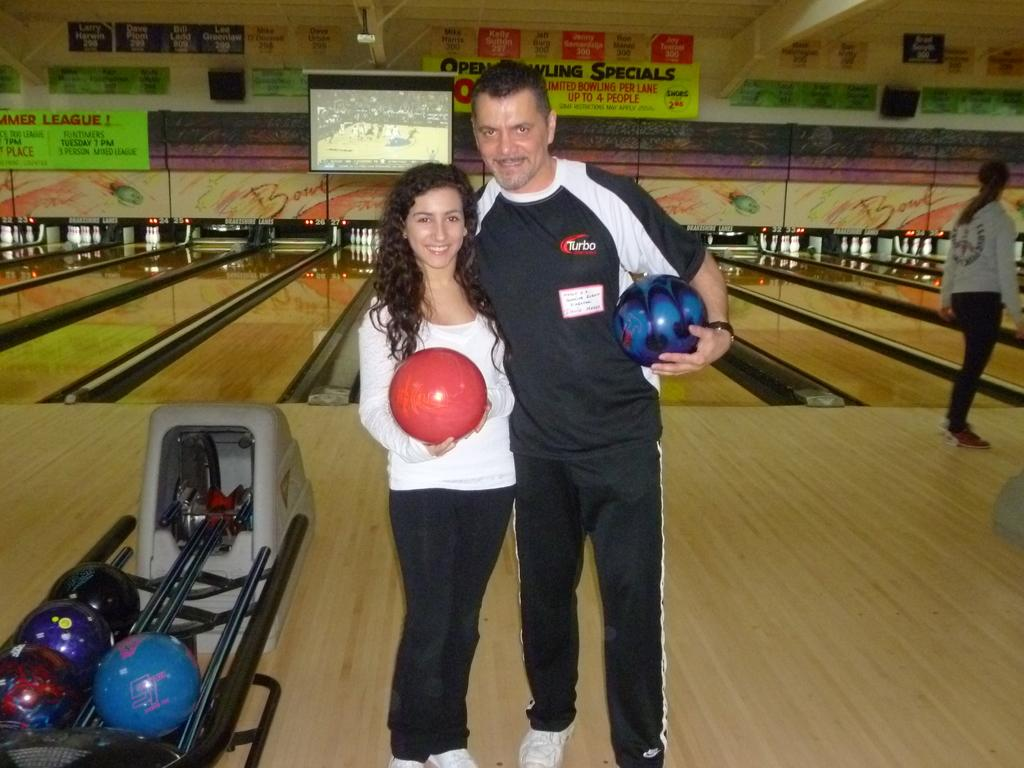<image>
Relay a brief, clear account of the picture shown. Man standing next to a woman, holding a bowling ball, and wearing a shirt with the logo Turbo on it. 